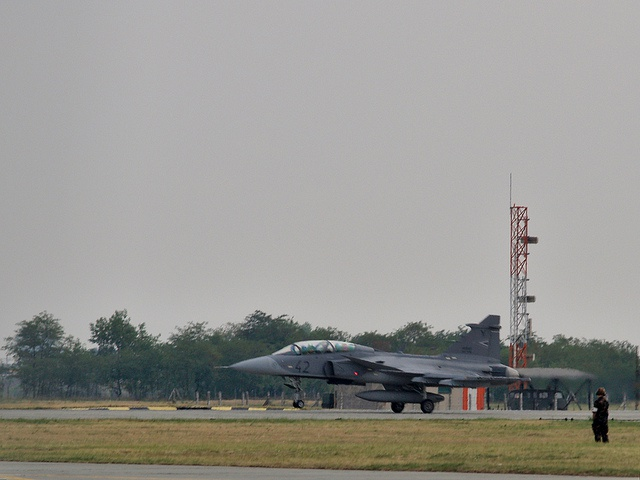Describe the objects in this image and their specific colors. I can see airplane in darkgray, gray, black, and purple tones and people in darkgray, black, gray, and darkgreen tones in this image. 